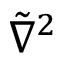<formula> <loc_0><loc_0><loc_500><loc_500>{ \tilde { \nabla } } ^ { 2 }</formula> 